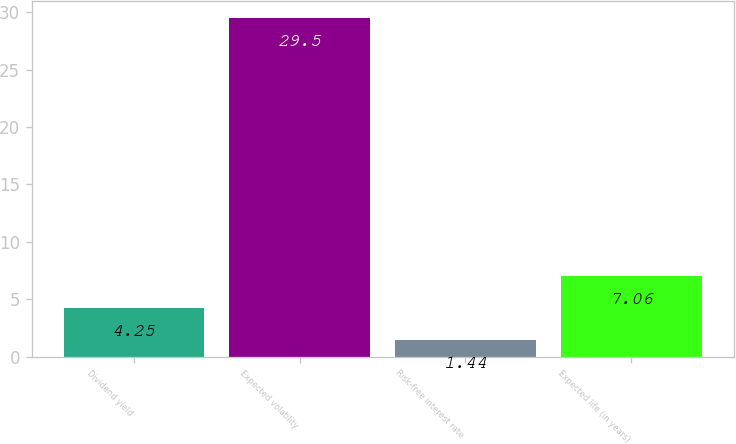Convert chart. <chart><loc_0><loc_0><loc_500><loc_500><bar_chart><fcel>Dividend yield<fcel>Expected volatility<fcel>Risk-free interest rate<fcel>Expected life (in years)<nl><fcel>4.25<fcel>29.5<fcel>1.44<fcel>7.06<nl></chart> 